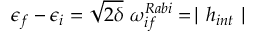<formula> <loc_0><loc_0><loc_500><loc_500>\epsilon _ { f } - \epsilon _ { i } = \sqrt { 2 \delta } \ \omega _ { i f } ^ { R a b i } = | h _ { i n t } |</formula> 